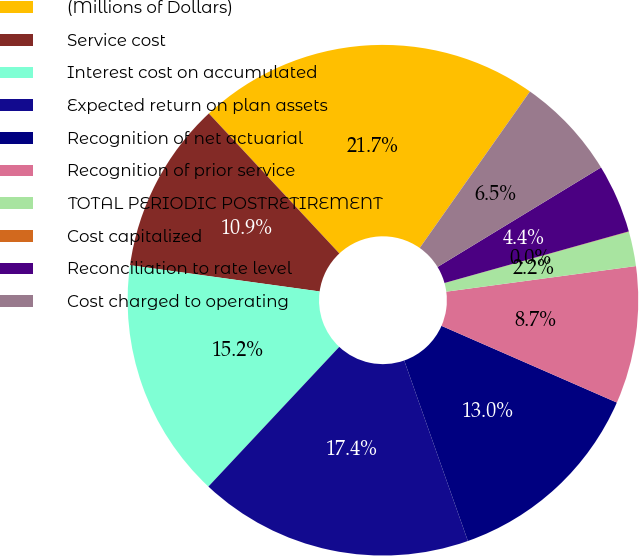Convert chart. <chart><loc_0><loc_0><loc_500><loc_500><pie_chart><fcel>(Millions of Dollars)<fcel>Service cost<fcel>Interest cost on accumulated<fcel>Expected return on plan assets<fcel>Recognition of net actuarial<fcel>Recognition of prior service<fcel>TOTAL PERIODIC POSTRETIREMENT<fcel>Cost capitalized<fcel>Reconciliation to rate level<fcel>Cost charged to operating<nl><fcel>21.71%<fcel>10.87%<fcel>15.21%<fcel>17.38%<fcel>13.04%<fcel>8.7%<fcel>2.19%<fcel>0.02%<fcel>4.36%<fcel>6.53%<nl></chart> 